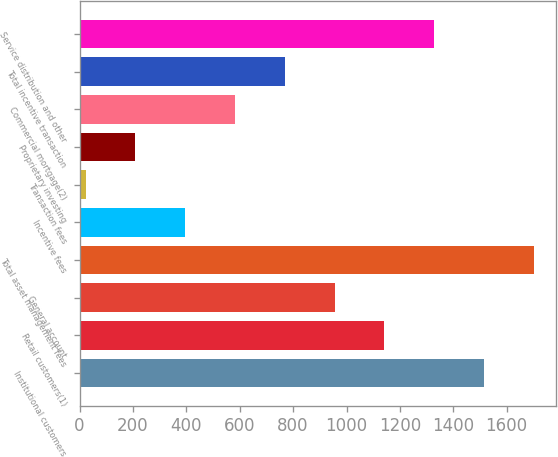<chart> <loc_0><loc_0><loc_500><loc_500><bar_chart><fcel>Institutional customers<fcel>Retail customers(1)<fcel>General account<fcel>Total asset management fees<fcel>Incentive fees<fcel>Transaction fees<fcel>Proprietary investing<fcel>Commercial mortgage(2)<fcel>Total incentive transaction<fcel>Service distribution and other<nl><fcel>1515<fcel>1142<fcel>955.5<fcel>1701.5<fcel>396<fcel>23<fcel>209.5<fcel>582.5<fcel>769<fcel>1328.5<nl></chart> 